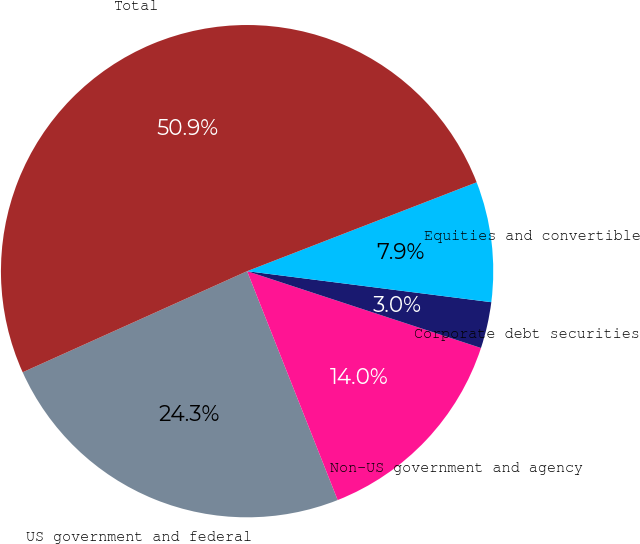<chart> <loc_0><loc_0><loc_500><loc_500><pie_chart><fcel>US government and federal<fcel>Non-US government and agency<fcel>Corporate debt securities<fcel>Equities and convertible<fcel>Total<nl><fcel>24.26%<fcel>13.95%<fcel>3.04%<fcel>7.89%<fcel>50.85%<nl></chart> 